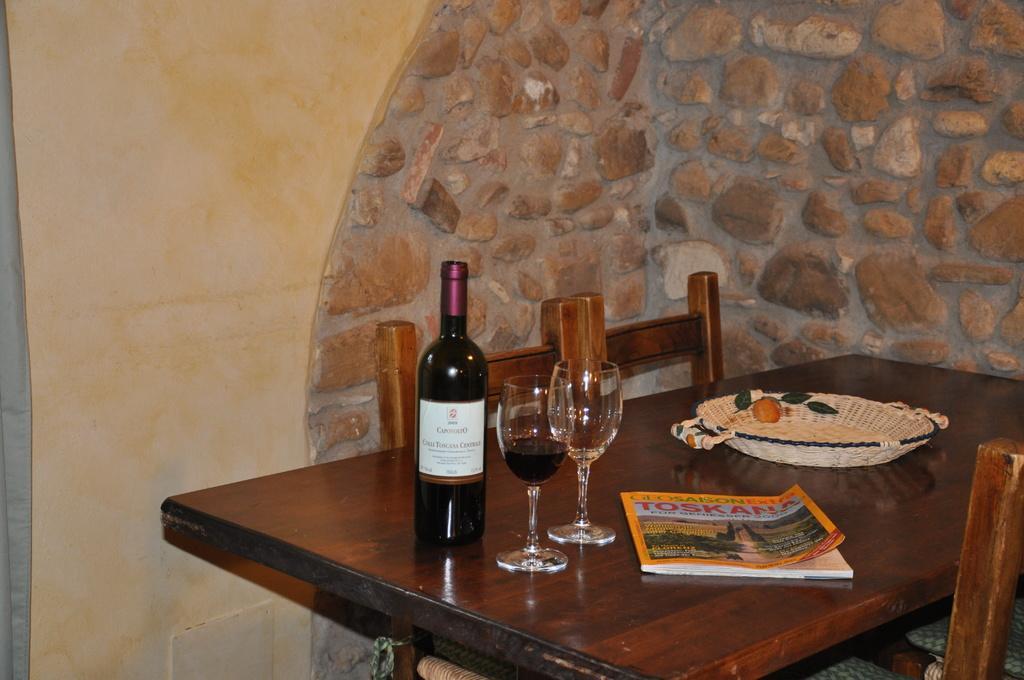Can you describe this image briefly? In this image we can see a wooden table where a wine bottle and two glasses, a basket and a magazine are kept on it. Here we can see chairs. 